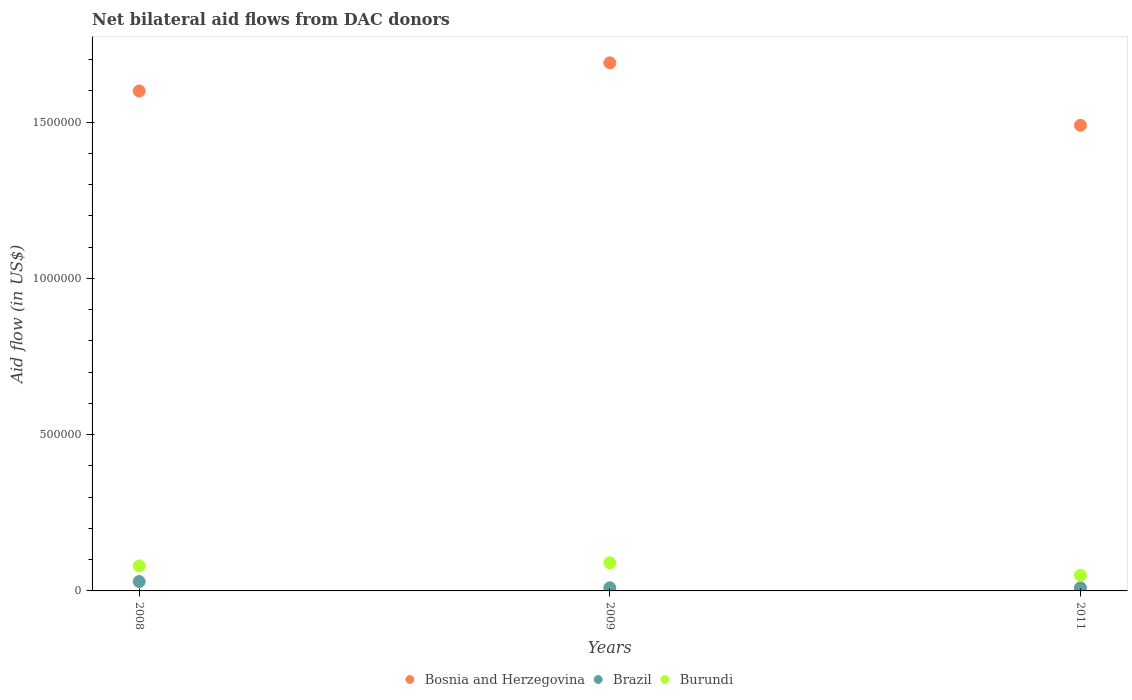Across all years, what is the maximum net bilateral aid flow in Brazil?
Offer a very short reply. 3.00e+04. Across all years, what is the minimum net bilateral aid flow in Bosnia and Herzegovina?
Keep it short and to the point. 1.49e+06. What is the total net bilateral aid flow in Burundi in the graph?
Provide a succinct answer. 2.20e+05. What is the difference between the net bilateral aid flow in Burundi in 2008 and that in 2011?
Give a very brief answer. 3.00e+04. What is the average net bilateral aid flow in Bosnia and Herzegovina per year?
Provide a succinct answer. 1.59e+06. In the year 2011, what is the difference between the net bilateral aid flow in Bosnia and Herzegovina and net bilateral aid flow in Burundi?
Ensure brevity in your answer.  1.44e+06. What is the ratio of the net bilateral aid flow in Burundi in 2008 to that in 2009?
Give a very brief answer. 0.89. Is the net bilateral aid flow in Burundi in 2008 less than that in 2009?
Give a very brief answer. Yes. In how many years, is the net bilateral aid flow in Bosnia and Herzegovina greater than the average net bilateral aid flow in Bosnia and Herzegovina taken over all years?
Offer a very short reply. 2. Is the sum of the net bilateral aid flow in Brazil in 2008 and 2011 greater than the maximum net bilateral aid flow in Burundi across all years?
Give a very brief answer. No. Is the net bilateral aid flow in Bosnia and Herzegovina strictly greater than the net bilateral aid flow in Burundi over the years?
Your answer should be compact. Yes. What is the difference between two consecutive major ticks on the Y-axis?
Ensure brevity in your answer.  5.00e+05. Are the values on the major ticks of Y-axis written in scientific E-notation?
Make the answer very short. No. What is the title of the graph?
Provide a short and direct response. Net bilateral aid flows from DAC donors. What is the label or title of the X-axis?
Make the answer very short. Years. What is the label or title of the Y-axis?
Ensure brevity in your answer.  Aid flow (in US$). What is the Aid flow (in US$) in Bosnia and Herzegovina in 2008?
Provide a short and direct response. 1.60e+06. What is the Aid flow (in US$) in Brazil in 2008?
Your answer should be very brief. 3.00e+04. What is the Aid flow (in US$) of Burundi in 2008?
Offer a very short reply. 8.00e+04. What is the Aid flow (in US$) in Bosnia and Herzegovina in 2009?
Give a very brief answer. 1.69e+06. What is the Aid flow (in US$) in Burundi in 2009?
Provide a succinct answer. 9.00e+04. What is the Aid flow (in US$) of Bosnia and Herzegovina in 2011?
Your answer should be compact. 1.49e+06. Across all years, what is the maximum Aid flow (in US$) in Bosnia and Herzegovina?
Provide a short and direct response. 1.69e+06. Across all years, what is the maximum Aid flow (in US$) in Burundi?
Ensure brevity in your answer.  9.00e+04. Across all years, what is the minimum Aid flow (in US$) in Bosnia and Herzegovina?
Offer a very short reply. 1.49e+06. Across all years, what is the minimum Aid flow (in US$) of Burundi?
Your answer should be compact. 5.00e+04. What is the total Aid flow (in US$) in Bosnia and Herzegovina in the graph?
Your answer should be very brief. 4.78e+06. What is the total Aid flow (in US$) of Brazil in the graph?
Your response must be concise. 5.00e+04. What is the total Aid flow (in US$) of Burundi in the graph?
Give a very brief answer. 2.20e+05. What is the difference between the Aid flow (in US$) of Bosnia and Herzegovina in 2008 and that in 2009?
Provide a short and direct response. -9.00e+04. What is the difference between the Aid flow (in US$) in Brazil in 2008 and that in 2009?
Give a very brief answer. 2.00e+04. What is the difference between the Aid flow (in US$) of Burundi in 2008 and that in 2009?
Keep it short and to the point. -10000. What is the difference between the Aid flow (in US$) in Bosnia and Herzegovina in 2008 and the Aid flow (in US$) in Brazil in 2009?
Offer a very short reply. 1.59e+06. What is the difference between the Aid flow (in US$) of Bosnia and Herzegovina in 2008 and the Aid flow (in US$) of Burundi in 2009?
Offer a very short reply. 1.51e+06. What is the difference between the Aid flow (in US$) of Bosnia and Herzegovina in 2008 and the Aid flow (in US$) of Brazil in 2011?
Offer a terse response. 1.59e+06. What is the difference between the Aid flow (in US$) of Bosnia and Herzegovina in 2008 and the Aid flow (in US$) of Burundi in 2011?
Provide a short and direct response. 1.55e+06. What is the difference between the Aid flow (in US$) of Brazil in 2008 and the Aid flow (in US$) of Burundi in 2011?
Offer a very short reply. -2.00e+04. What is the difference between the Aid flow (in US$) in Bosnia and Herzegovina in 2009 and the Aid flow (in US$) in Brazil in 2011?
Provide a succinct answer. 1.68e+06. What is the difference between the Aid flow (in US$) of Bosnia and Herzegovina in 2009 and the Aid flow (in US$) of Burundi in 2011?
Offer a terse response. 1.64e+06. What is the difference between the Aid flow (in US$) of Brazil in 2009 and the Aid flow (in US$) of Burundi in 2011?
Your answer should be compact. -4.00e+04. What is the average Aid flow (in US$) of Bosnia and Herzegovina per year?
Provide a succinct answer. 1.59e+06. What is the average Aid flow (in US$) of Brazil per year?
Provide a succinct answer. 1.67e+04. What is the average Aid flow (in US$) in Burundi per year?
Ensure brevity in your answer.  7.33e+04. In the year 2008, what is the difference between the Aid flow (in US$) in Bosnia and Herzegovina and Aid flow (in US$) in Brazil?
Your answer should be compact. 1.57e+06. In the year 2008, what is the difference between the Aid flow (in US$) of Bosnia and Herzegovina and Aid flow (in US$) of Burundi?
Your answer should be compact. 1.52e+06. In the year 2008, what is the difference between the Aid flow (in US$) in Brazil and Aid flow (in US$) in Burundi?
Provide a short and direct response. -5.00e+04. In the year 2009, what is the difference between the Aid flow (in US$) in Bosnia and Herzegovina and Aid flow (in US$) in Brazil?
Keep it short and to the point. 1.68e+06. In the year 2009, what is the difference between the Aid flow (in US$) in Bosnia and Herzegovina and Aid flow (in US$) in Burundi?
Your answer should be compact. 1.60e+06. In the year 2009, what is the difference between the Aid flow (in US$) of Brazil and Aid flow (in US$) of Burundi?
Your answer should be very brief. -8.00e+04. In the year 2011, what is the difference between the Aid flow (in US$) of Bosnia and Herzegovina and Aid flow (in US$) of Brazil?
Give a very brief answer. 1.48e+06. In the year 2011, what is the difference between the Aid flow (in US$) in Bosnia and Herzegovina and Aid flow (in US$) in Burundi?
Offer a very short reply. 1.44e+06. In the year 2011, what is the difference between the Aid flow (in US$) of Brazil and Aid flow (in US$) of Burundi?
Keep it short and to the point. -4.00e+04. What is the ratio of the Aid flow (in US$) of Bosnia and Herzegovina in 2008 to that in 2009?
Your response must be concise. 0.95. What is the ratio of the Aid flow (in US$) in Brazil in 2008 to that in 2009?
Offer a terse response. 3. What is the ratio of the Aid flow (in US$) in Burundi in 2008 to that in 2009?
Your answer should be compact. 0.89. What is the ratio of the Aid flow (in US$) of Bosnia and Herzegovina in 2008 to that in 2011?
Your answer should be very brief. 1.07. What is the ratio of the Aid flow (in US$) of Brazil in 2008 to that in 2011?
Ensure brevity in your answer.  3. What is the ratio of the Aid flow (in US$) in Bosnia and Herzegovina in 2009 to that in 2011?
Provide a short and direct response. 1.13. What is the ratio of the Aid flow (in US$) of Brazil in 2009 to that in 2011?
Provide a succinct answer. 1. What is the difference between the highest and the second highest Aid flow (in US$) of Bosnia and Herzegovina?
Your response must be concise. 9.00e+04. What is the difference between the highest and the second highest Aid flow (in US$) of Brazil?
Your answer should be very brief. 2.00e+04. What is the difference between the highest and the second highest Aid flow (in US$) in Burundi?
Give a very brief answer. 10000. What is the difference between the highest and the lowest Aid flow (in US$) of Brazil?
Your answer should be compact. 2.00e+04. What is the difference between the highest and the lowest Aid flow (in US$) in Burundi?
Offer a very short reply. 4.00e+04. 